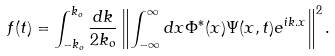<formula> <loc_0><loc_0><loc_500><loc_500>f ( t ) = \int _ { - k _ { o } } ^ { k _ { o } } \frac { d k } { 2 k _ { o } } \left \| \int _ { - \infty } ^ { \infty } d x \Phi ^ { * } ( x ) \Psi ( x , t ) e ^ { i k . x } \right \| ^ { 2 } .</formula> 